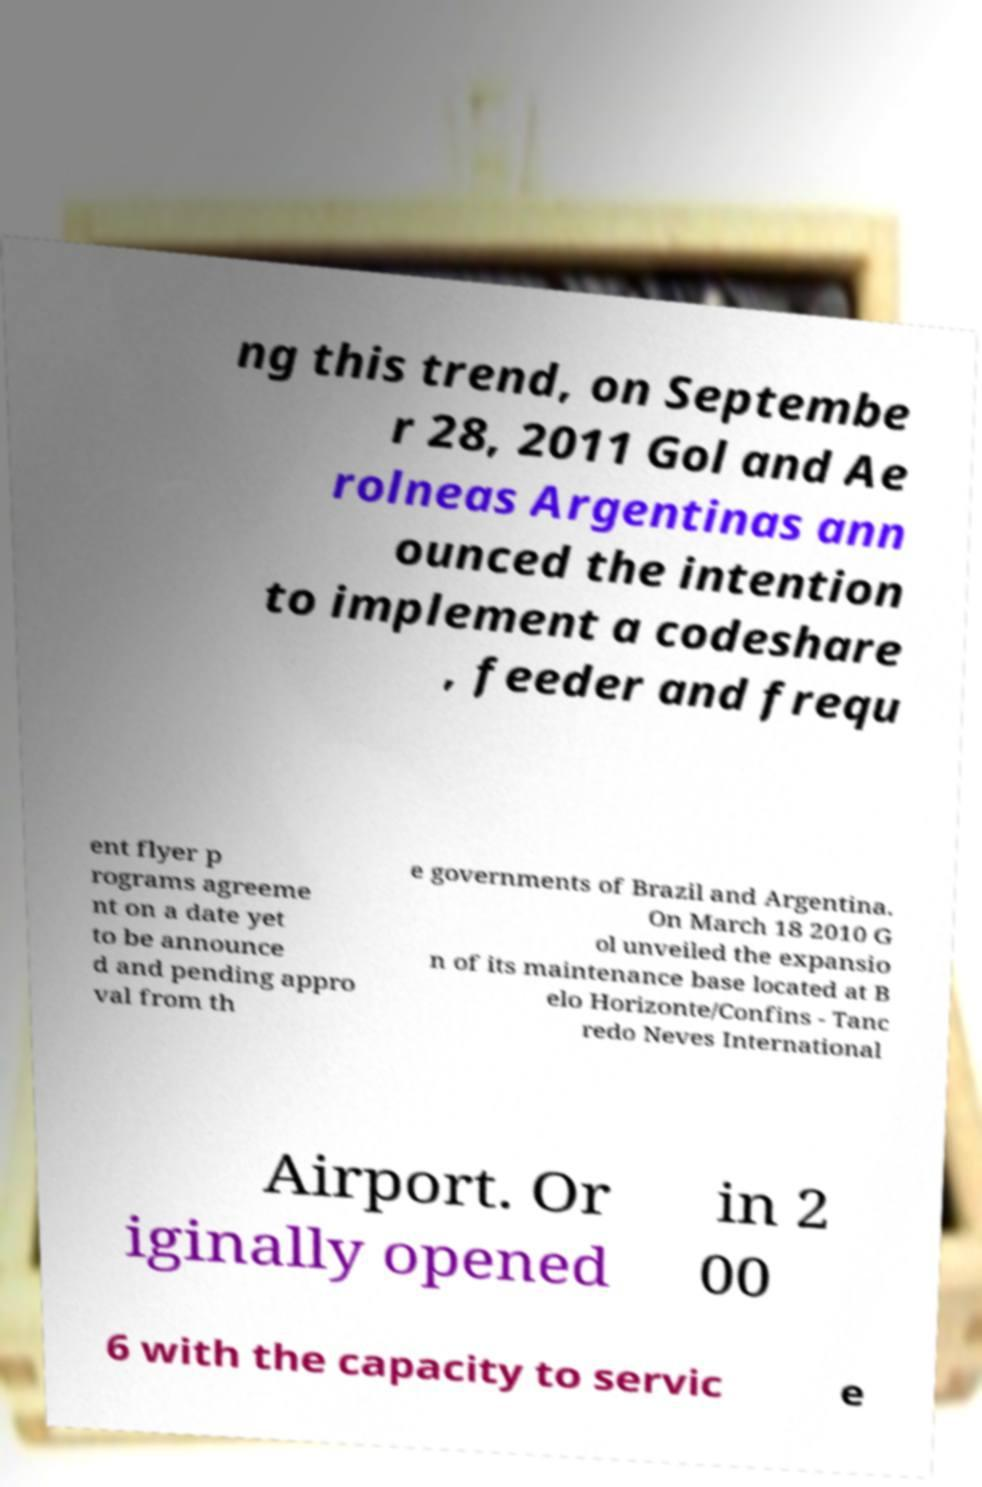Please read and relay the text visible in this image. What does it say? ng this trend, on Septembe r 28, 2011 Gol and Ae rolneas Argentinas ann ounced the intention to implement a codeshare , feeder and frequ ent flyer p rograms agreeme nt on a date yet to be announce d and pending appro val from th e governments of Brazil and Argentina. On March 18 2010 G ol unveiled the expansio n of its maintenance base located at B elo Horizonte/Confins - Tanc redo Neves International Airport. Or iginally opened in 2 00 6 with the capacity to servic e 